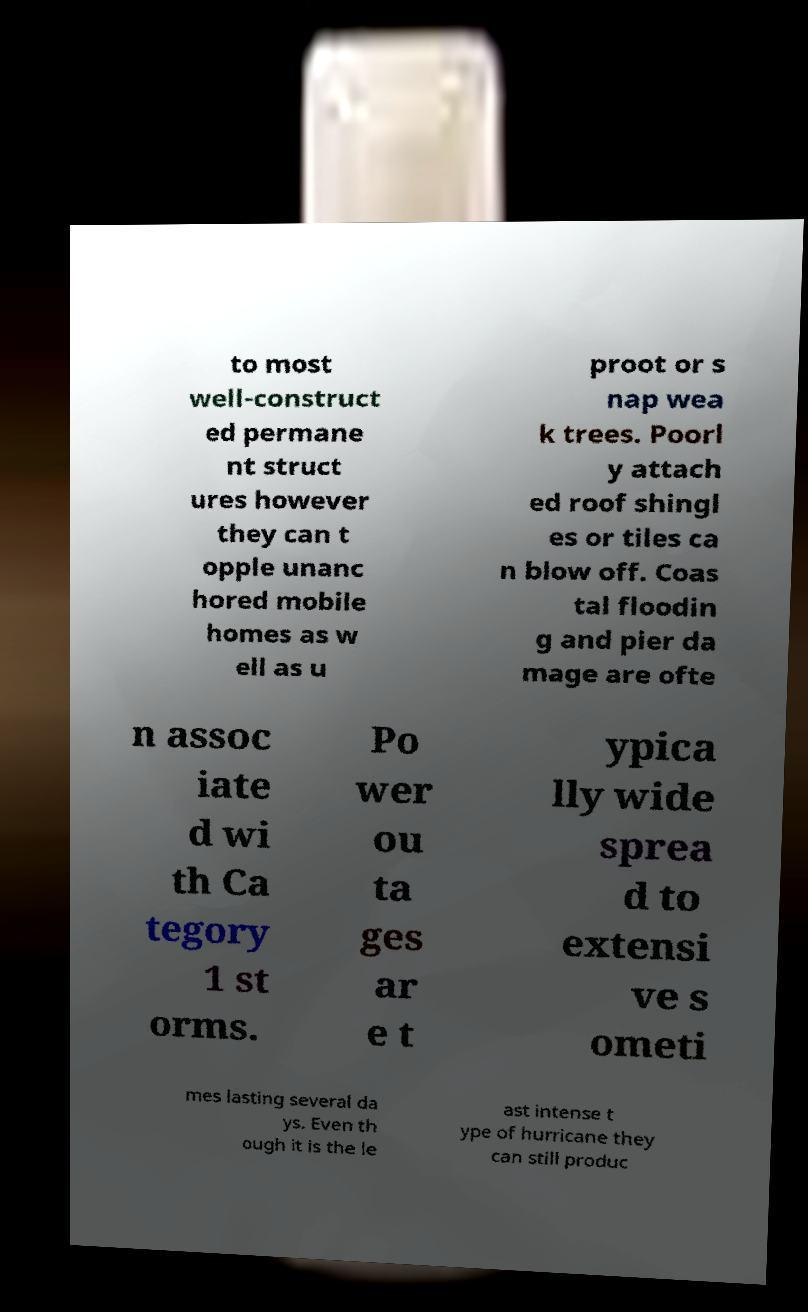Please identify and transcribe the text found in this image. to most well-construct ed permane nt struct ures however they can t opple unanc hored mobile homes as w ell as u proot or s nap wea k trees. Poorl y attach ed roof shingl es or tiles ca n blow off. Coas tal floodin g and pier da mage are ofte n assoc iate d wi th Ca tegory 1 st orms. Po wer ou ta ges ar e t ypica lly wide sprea d to extensi ve s ometi mes lasting several da ys. Even th ough it is the le ast intense t ype of hurricane they can still produc 